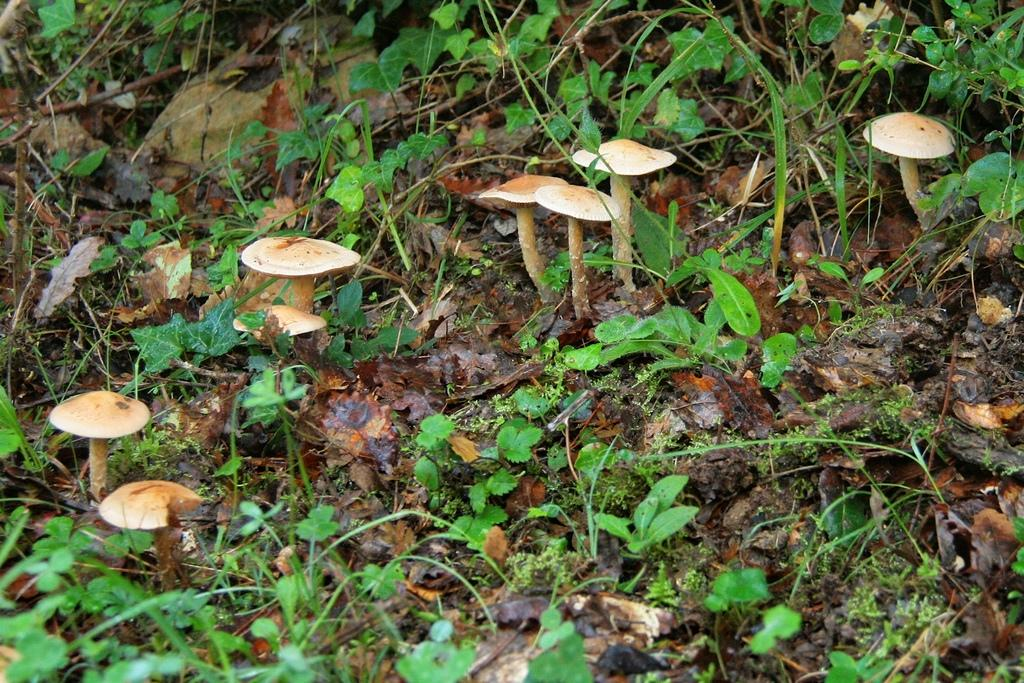What type of fungi can be seen in the image? There are mushrooms in the image. Where are the mushrooms located? The mushrooms are on the land in the image. What other types of vegetation are present in the image? There are plants in the image. What additional feature can be observed in the image? Dried leaves are present in the image. What type of kitten can be seen playing in space in the image? There is no kitten or space present in the image; it features mushrooms, plants, and dried leaves on land. Who is the creator of the mushrooms in the image? The image does not provide information about the creator of the mushrooms; it simply shows their presence in the environment. 